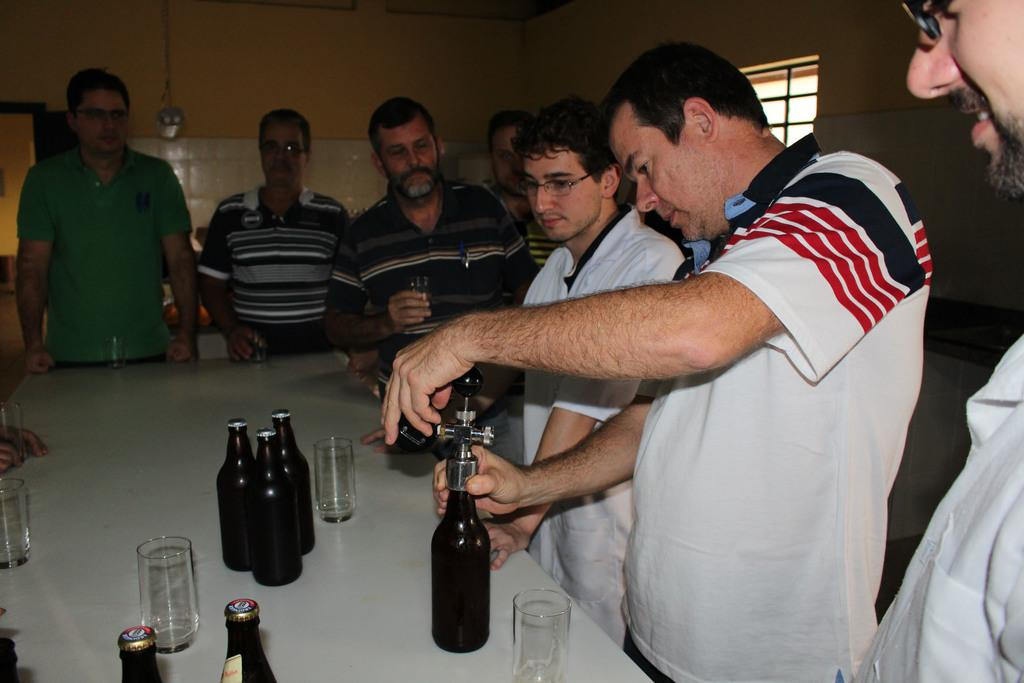How many people are in the image? There is a group of people in the image. What are the people doing in the image? The people are standing in front of a table. What items can be seen on the table? There are glasses and bottles on the table. What action is being performed by one of the people in the image? A person in the front is opening the cap of a bottle. What type of laborer is working on the throat of the person in the image? There is no laborer or throat-related activity present in the image. 